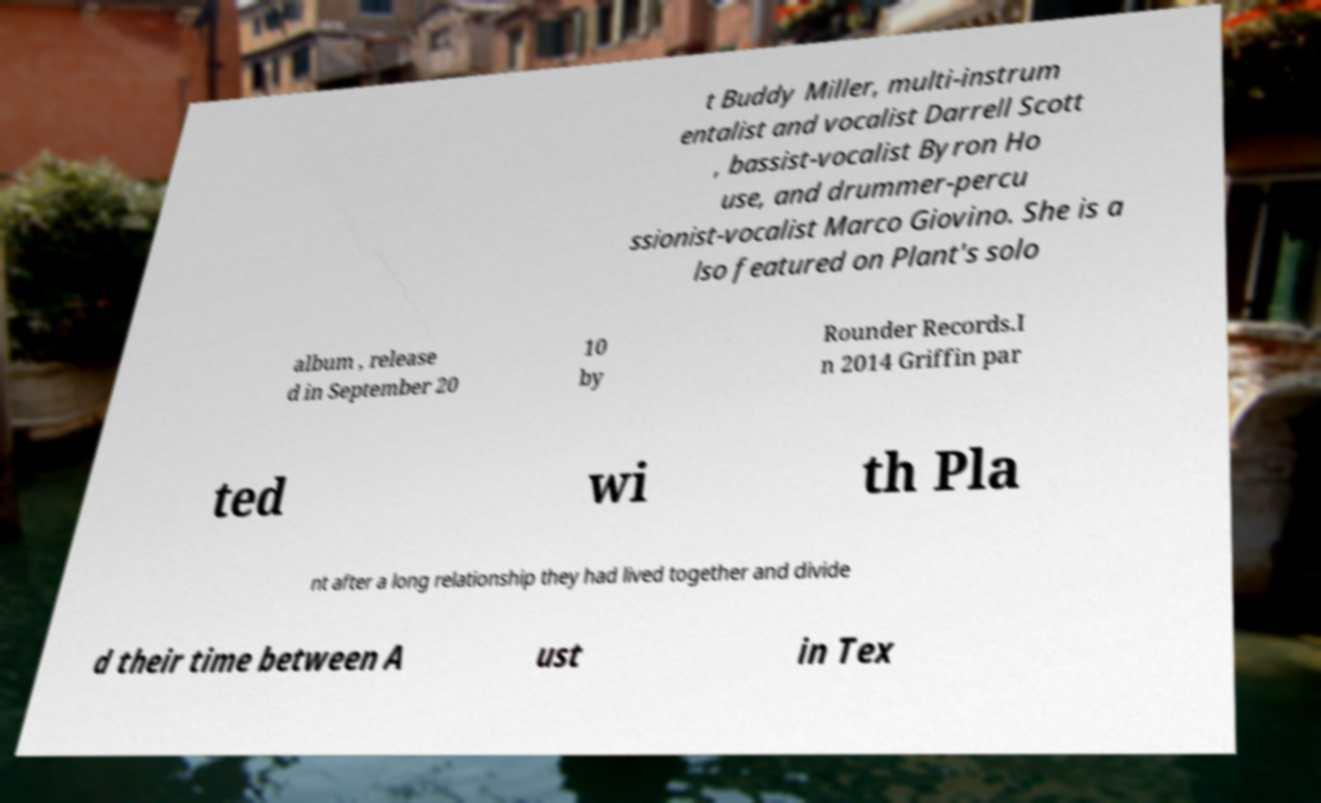Can you accurately transcribe the text from the provided image for me? t Buddy Miller, multi-instrum entalist and vocalist Darrell Scott , bassist-vocalist Byron Ho use, and drummer-percu ssionist-vocalist Marco Giovino. She is a lso featured on Plant's solo album , release d in September 20 10 by Rounder Records.I n 2014 Griffin par ted wi th Pla nt after a long relationship they had lived together and divide d their time between A ust in Tex 